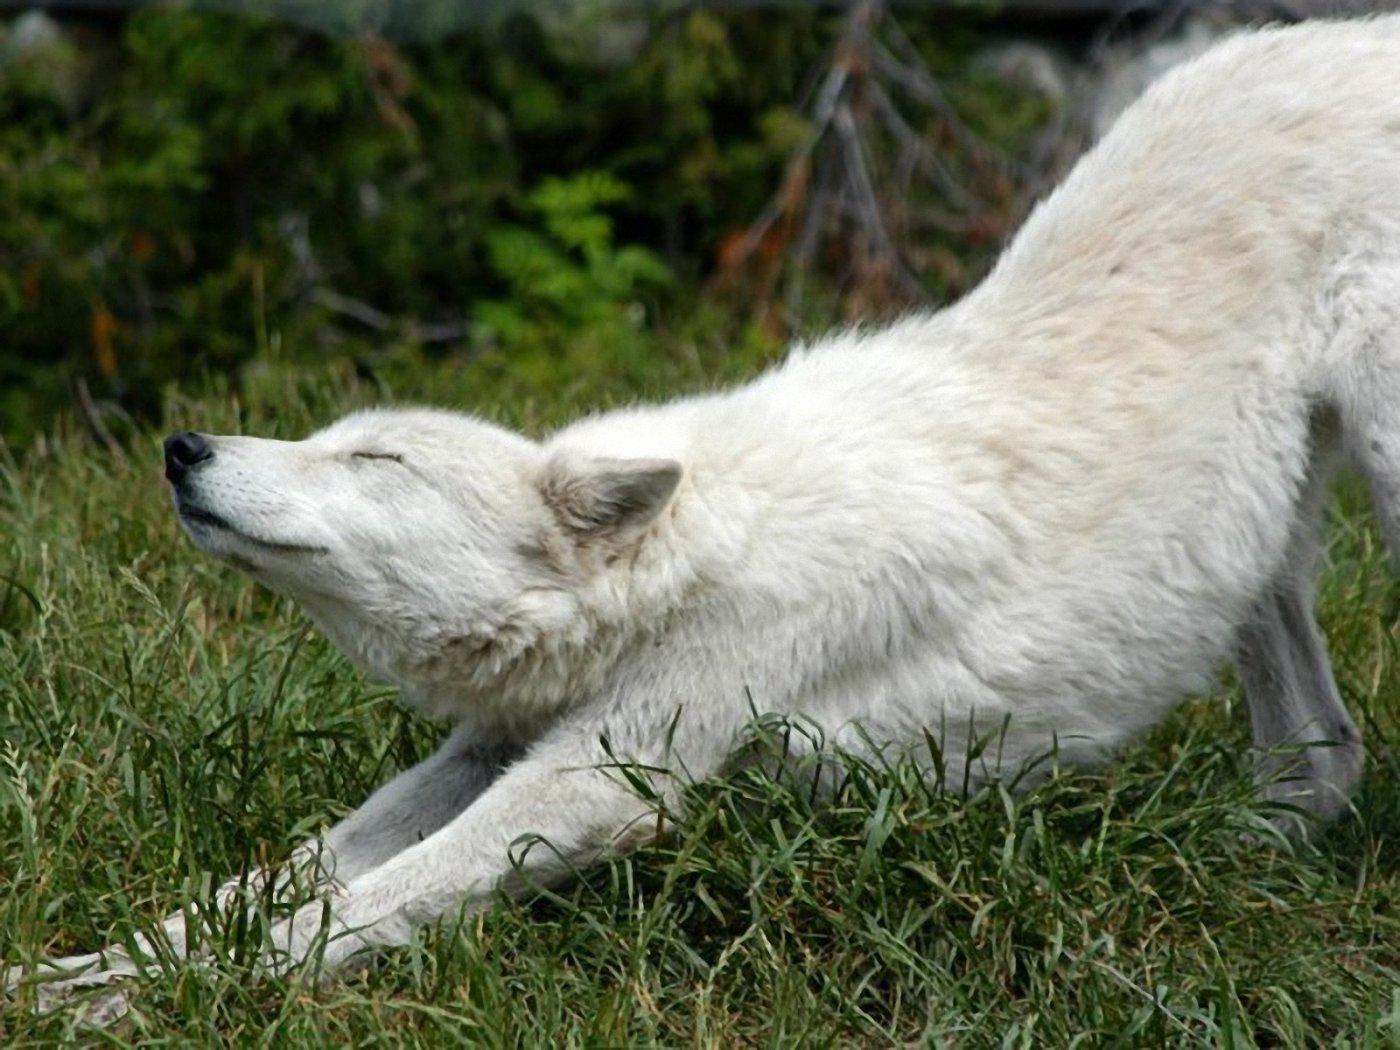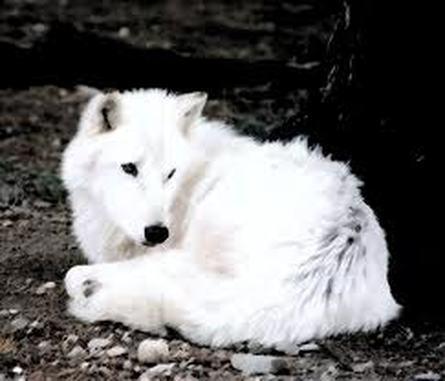The first image is the image on the left, the second image is the image on the right. For the images displayed, is the sentence "Each image shows a reclining white dog with fully closed eyes, and the dogs in the left and right images look similar in terms of size, coloring, breed and ear position." factually correct? Answer yes or no. No. The first image is the image on the left, the second image is the image on the right. Considering the images on both sides, is "At least one white wolf has its eyes open." valid? Answer yes or no. Yes. 